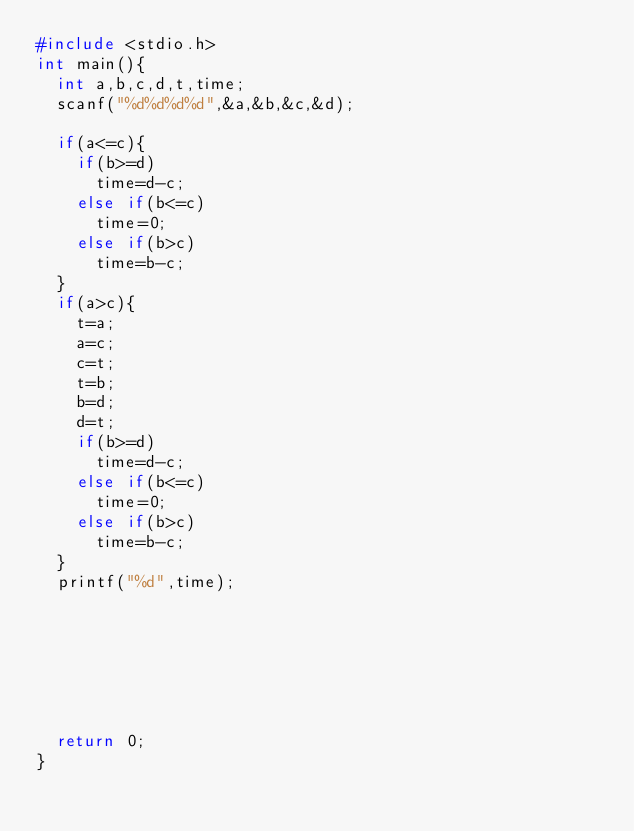Convert code to text. <code><loc_0><loc_0><loc_500><loc_500><_C_>#include <stdio.h>
int main(){
	int a,b,c,d,t,time;
	scanf("%d%d%d%d",&a,&b,&c,&d);

	if(a<=c){
		if(b>=d)
			time=d-c;	
		else if(b<=c)
			time=0; 
		else if(b>c)
			time=b-c;	
	}
	if(a>c){
		t=a;
		a=c;
		c=t;
		t=b;
		b=d;
		d=t;
		if(b>=d)
			time=d-c;	
		else if(b<=c)
			time=0; 
		else if(b>c)
			time=b-c;		
	}
	printf("%d",time);
	
	
	
	
	
	
	
	return 0;
} </code> 